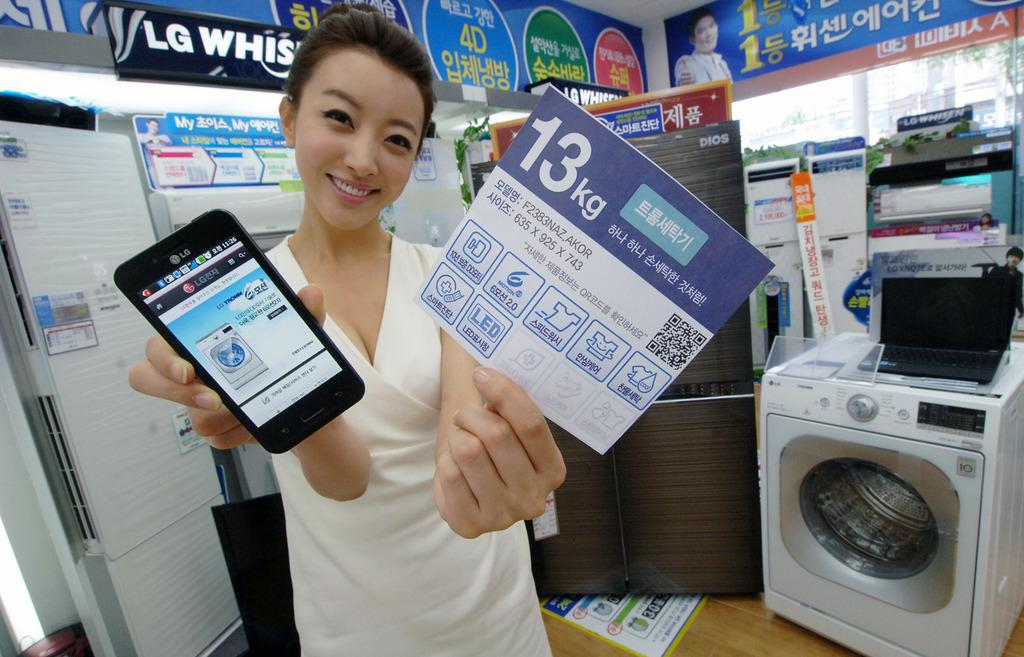<image>
Give a short and clear explanation of the subsequent image. A woman is holding up a LG phone that has an LG appliance on the screen. 